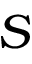<formula> <loc_0><loc_0><loc_500><loc_500>S</formula> 